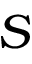<formula> <loc_0><loc_0><loc_500><loc_500>S</formula> 